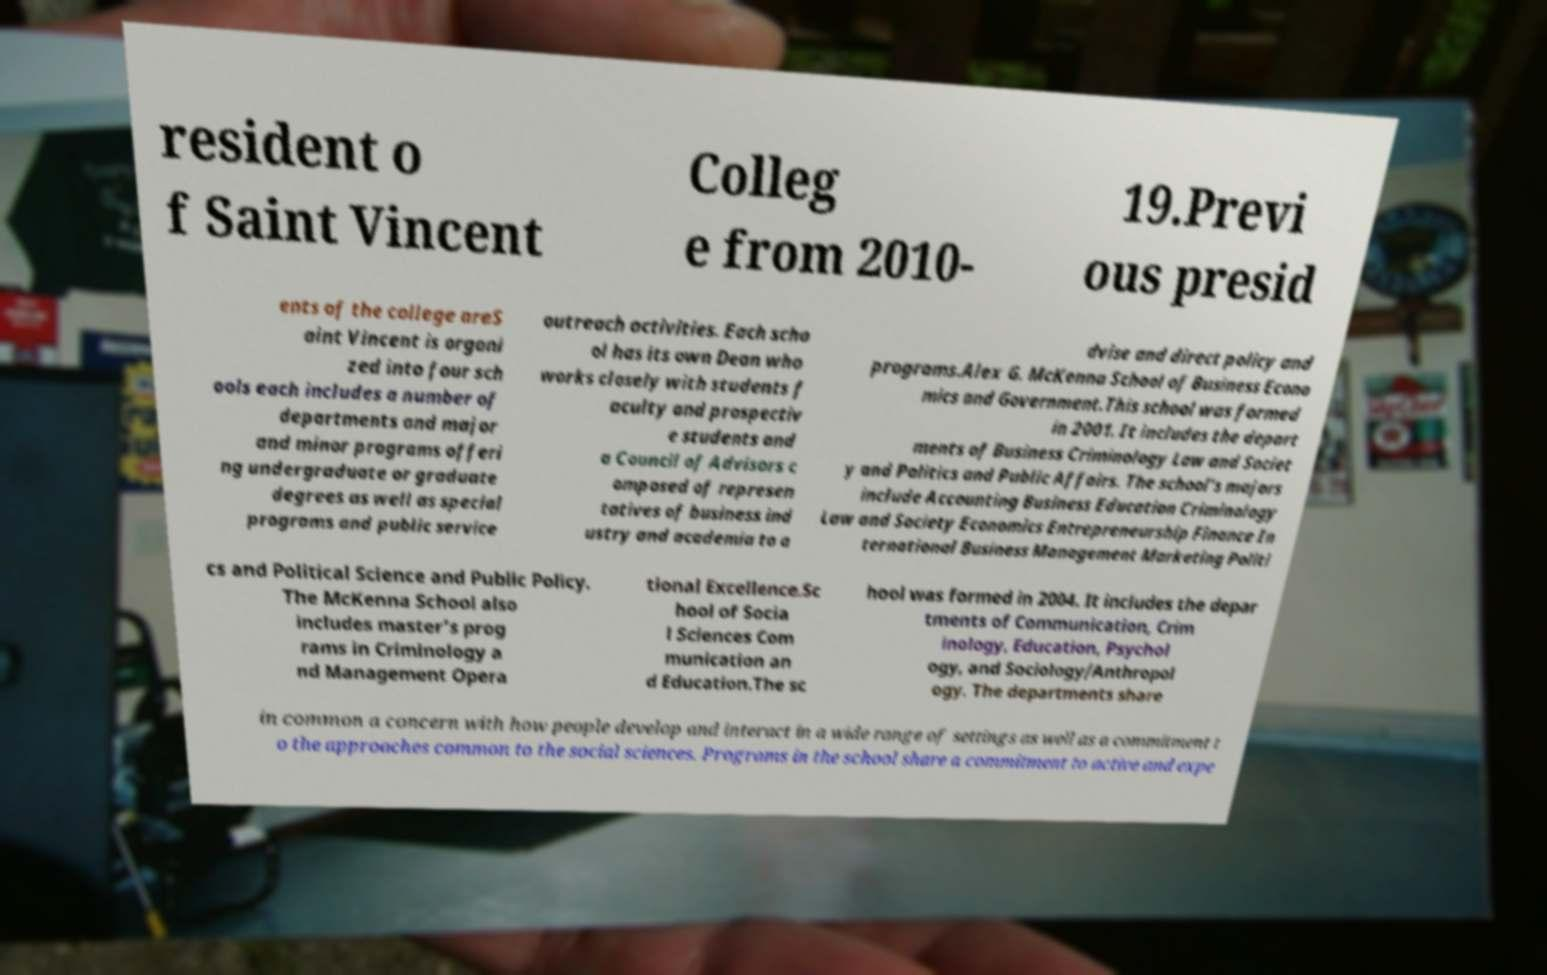For documentation purposes, I need the text within this image transcribed. Could you provide that? resident o f Saint Vincent Colleg e from 2010- 19.Previ ous presid ents of the college areS aint Vincent is organi zed into four sch ools each includes a number of departments and major and minor programs offeri ng undergraduate or graduate degrees as well as special programs and public service outreach activities. Each scho ol has its own Dean who works closely with students f aculty and prospectiv e students and a Council of Advisors c omposed of represen tatives of business ind ustry and academia to a dvise and direct policy and programs.Alex G. McKenna School of Business Econo mics and Government.This school was formed in 2001. It includes the depart ments of Business Criminology Law and Societ y and Politics and Public Affairs. The school’s majors include Accounting Business Education Criminology Law and Society Economics Entrepreneurship Finance In ternational Business Management Marketing Politi cs and Political Science and Public Policy. The McKenna School also includes master’s prog rams in Criminology a nd Management Opera tional Excellence.Sc hool of Socia l Sciences Com munication an d Education.The sc hool was formed in 2004. It includes the depar tments of Communication, Crim inology, Education, Psychol ogy, and Sociology/Anthropol ogy. The departments share in common a concern with how people develop and interact in a wide range of settings as well as a commitment t o the approaches common to the social sciences. Programs in the school share a commitment to active and expe 